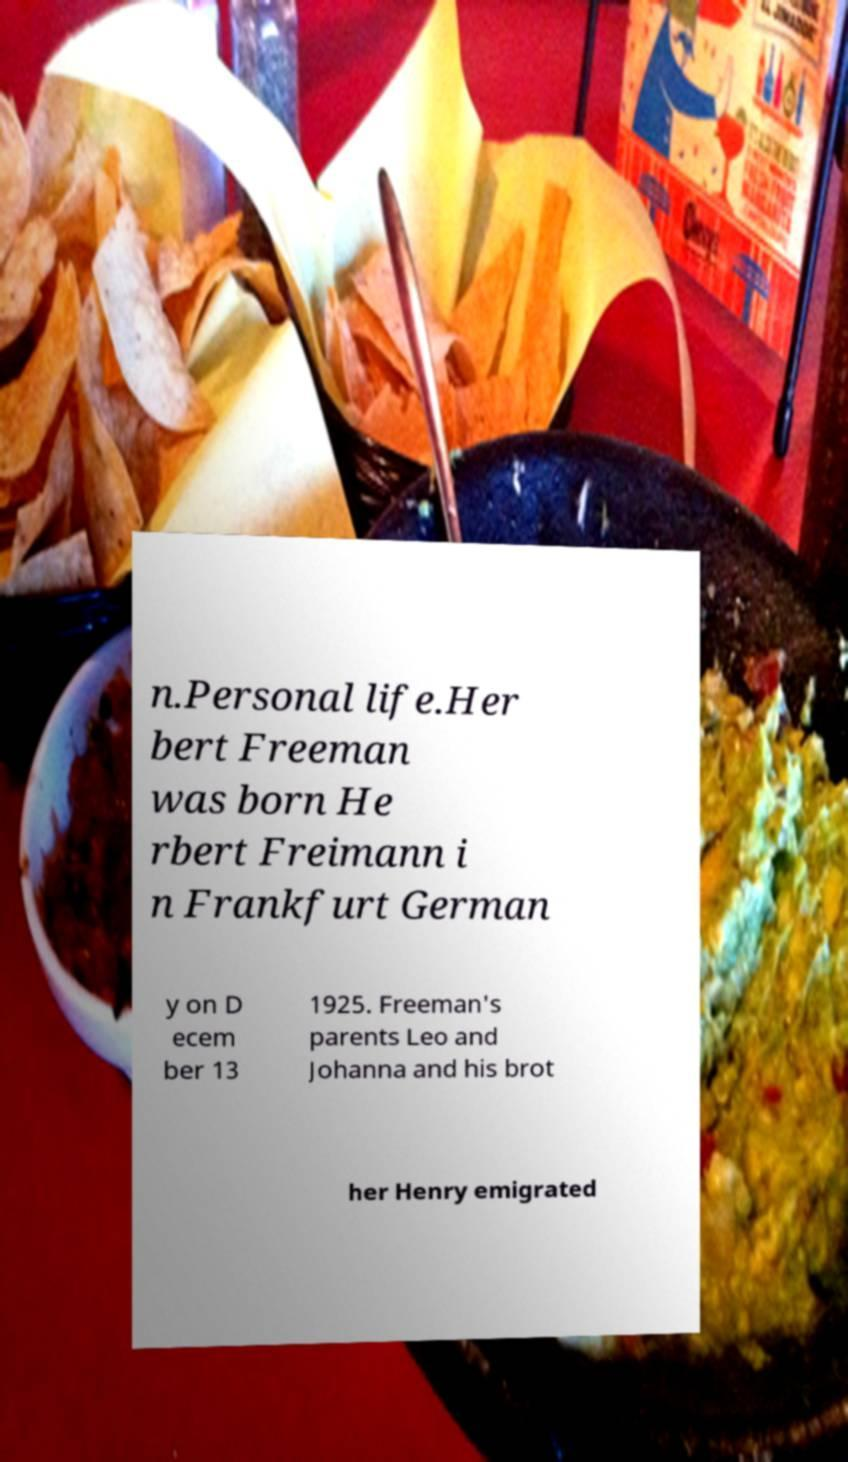Please read and relay the text visible in this image. What does it say? n.Personal life.Her bert Freeman was born He rbert Freimann i n Frankfurt German y on D ecem ber 13 1925. Freeman's parents Leo and Johanna and his brot her Henry emigrated 